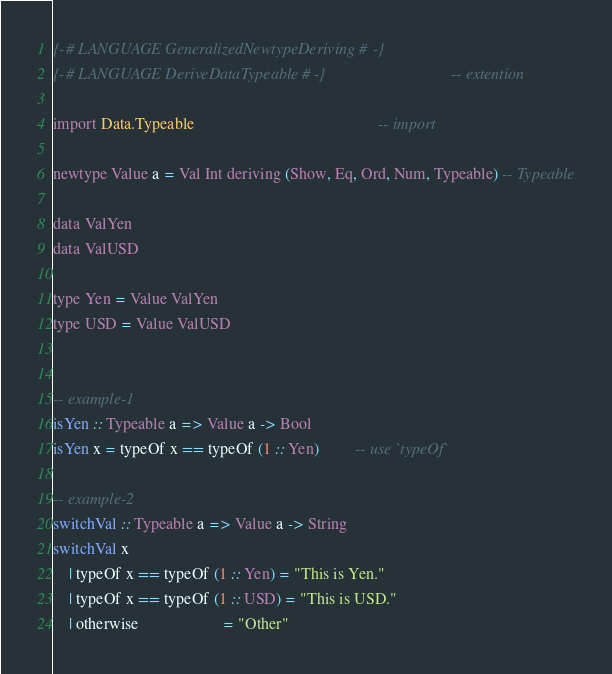Convert code to text. <code><loc_0><loc_0><loc_500><loc_500><_Haskell_>
{-# LANGUAGE GeneralizedNewtypeDeriving #-}
{-# LANGUAGE DeriveDataTypeable #-}                               -- extention

import Data.Typeable                                              -- import

newtype Value a = Val Int deriving (Show, Eq, Ord, Num, Typeable) -- Typeable

data ValYen
data ValUSD

type Yen = Value ValYen
type USD = Value ValUSD


-- example-1
isYen :: Typeable a => Value a -> Bool
isYen x = typeOf x == typeOf (1 :: Yen)         -- use `typeOf`

-- example-2
switchVal :: Typeable a => Value a -> String
switchVal x
    | typeOf x == typeOf (1 :: Yen) = "This is Yen."
    | typeOf x == typeOf (1 :: USD) = "This is USD."
    | otherwise                     = "Other"

</code> 